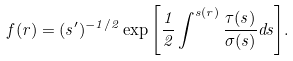Convert formula to latex. <formula><loc_0><loc_0><loc_500><loc_500>f ( r ) = ( s ^ { \prime } ) ^ { - 1 / 2 } \exp { \left [ \frac { 1 } { 2 } \int ^ { s ( r ) } \frac { \tau ( s ) } { \sigma ( s ) } d s \right ] } .</formula> 